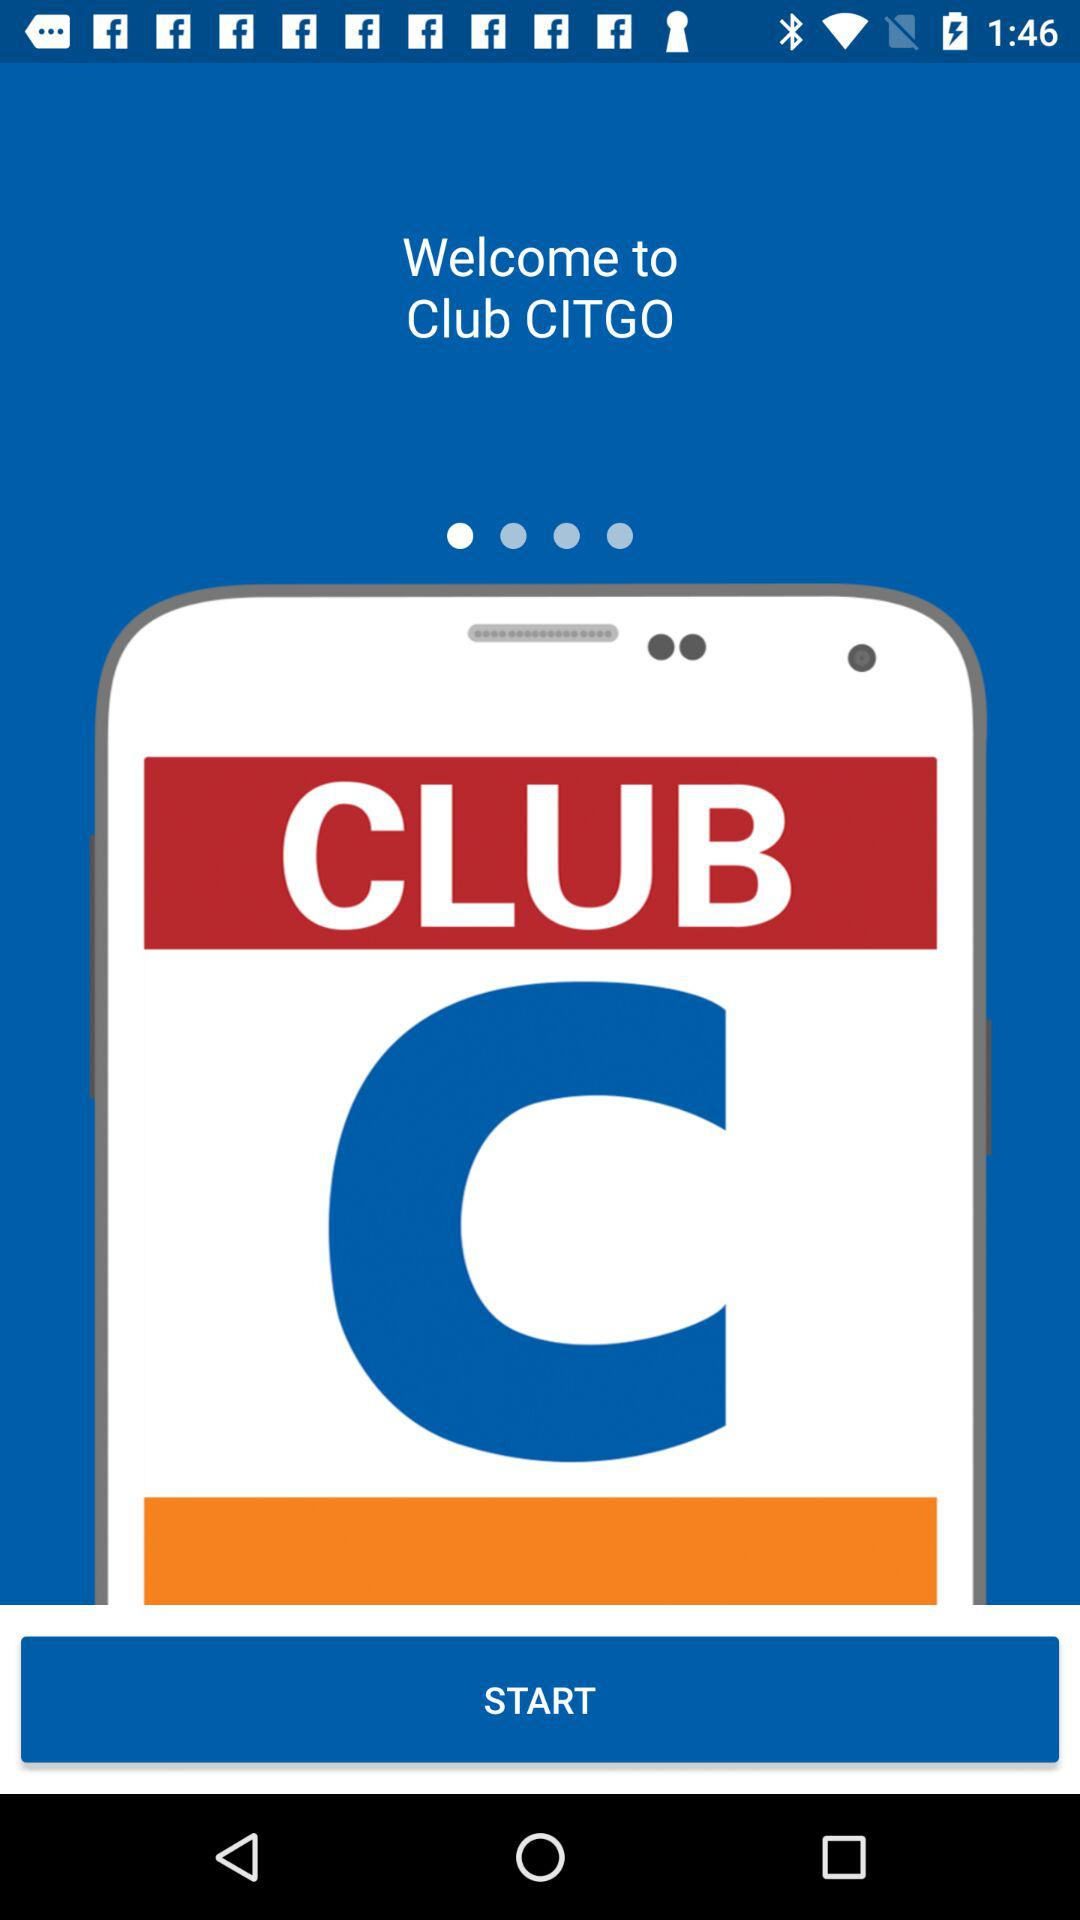What does "Club CITGO" do?
When the provided information is insufficient, respond with <no answer>. <no answer> 